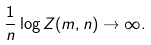Convert formula to latex. <formula><loc_0><loc_0><loc_500><loc_500>\frac { 1 } { n } \log Z ( m , n ) \to \infty .</formula> 